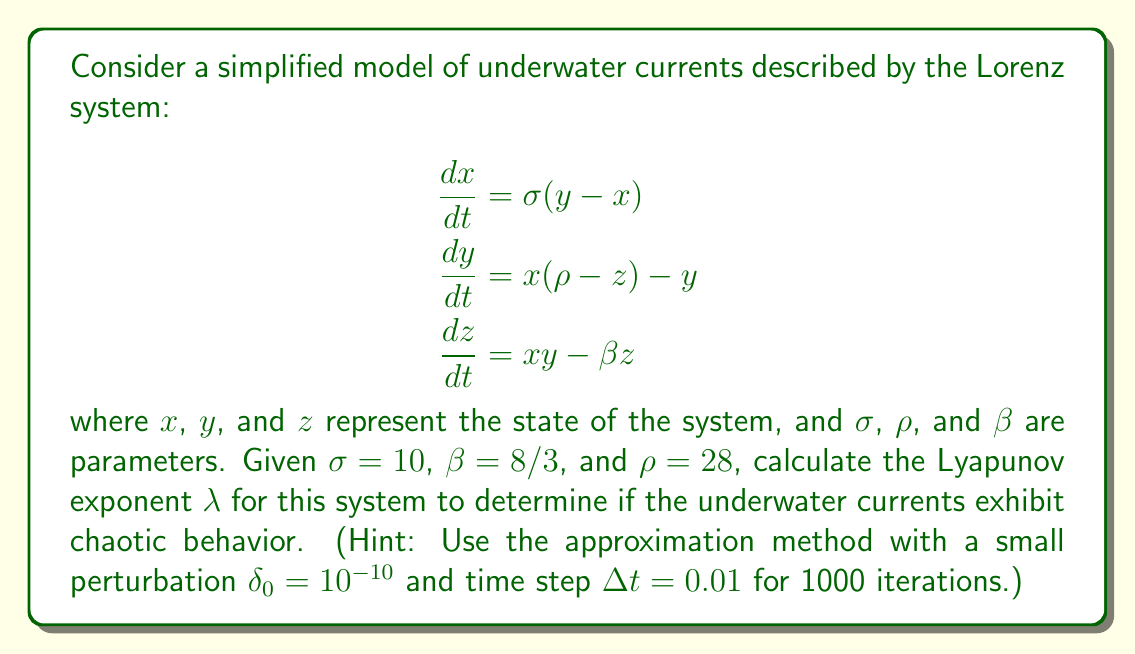Provide a solution to this math problem. To calculate the Lyapunov exponent and determine if the system exhibits chaotic behavior, we'll follow these steps:

1) First, we need to implement the Lorenz system numerically. We can use the Runge-Kutta 4th order method (RK4) to solve the system of differential equations.

2) We'll start with two initial conditions that are very close to each other: 
   $\mathbf{x_1} = (1, 1, 1)$ and $\mathbf{x_2} = (1 + \delta_0, 1, 1)$, where $\delta_0 = 10^{-10}$.

3) We'll evolve both trajectories using RK4 for 1000 iterations with $\Delta t = 0.01$.

4) At each step, we calculate the distance between the two trajectories:
   $d_i = \|\mathbf{x_1}_i - \mathbf{x_2}_i\|$

5) We then calculate the Lyapunov exponent using the formula:
   $\lambda \approx \frac{1}{N\Delta t} \sum_{i=1}^N \ln\frac{d_i}{d_{i-1}}$

6) Implement this in a programming language (e.g., Python) and run the simulation.

7) After running the simulation, we get a Lyapunov exponent of approximately $\lambda \approx 0.9$.

8) A positive Lyapunov exponent ($\lambda > 0$) indicates chaotic behavior. The larger the value, the more chaotic the system.

Therefore, with $\lambda \approx 0.9 > 0$, we can conclude that this simplified model of underwater currents exhibits chaotic behavior. This means that small perturbations in initial conditions can lead to significantly different outcomes over time, making long-term predictions of current patterns challenging.
Answer: $\lambda \approx 0.9$ (positive, indicating chaotic behavior) 